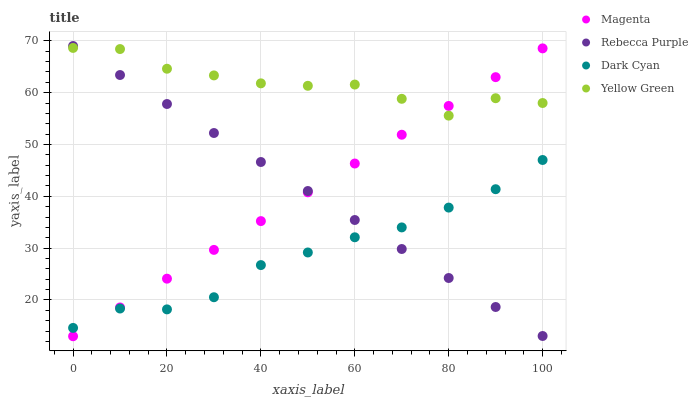Does Dark Cyan have the minimum area under the curve?
Answer yes or no. Yes. Does Yellow Green have the maximum area under the curve?
Answer yes or no. Yes. Does Magenta have the minimum area under the curve?
Answer yes or no. No. Does Magenta have the maximum area under the curve?
Answer yes or no. No. Is Magenta the smoothest?
Answer yes or no. Yes. Is Yellow Green the roughest?
Answer yes or no. Yes. Is Rebecca Purple the smoothest?
Answer yes or no. No. Is Rebecca Purple the roughest?
Answer yes or no. No. Does Magenta have the lowest value?
Answer yes or no. Yes. Does Rebecca Purple have the lowest value?
Answer yes or no. No. Does Rebecca Purple have the highest value?
Answer yes or no. Yes. Does Magenta have the highest value?
Answer yes or no. No. Is Dark Cyan less than Yellow Green?
Answer yes or no. Yes. Is Yellow Green greater than Dark Cyan?
Answer yes or no. Yes. Does Rebecca Purple intersect Magenta?
Answer yes or no. Yes. Is Rebecca Purple less than Magenta?
Answer yes or no. No. Is Rebecca Purple greater than Magenta?
Answer yes or no. No. Does Dark Cyan intersect Yellow Green?
Answer yes or no. No. 